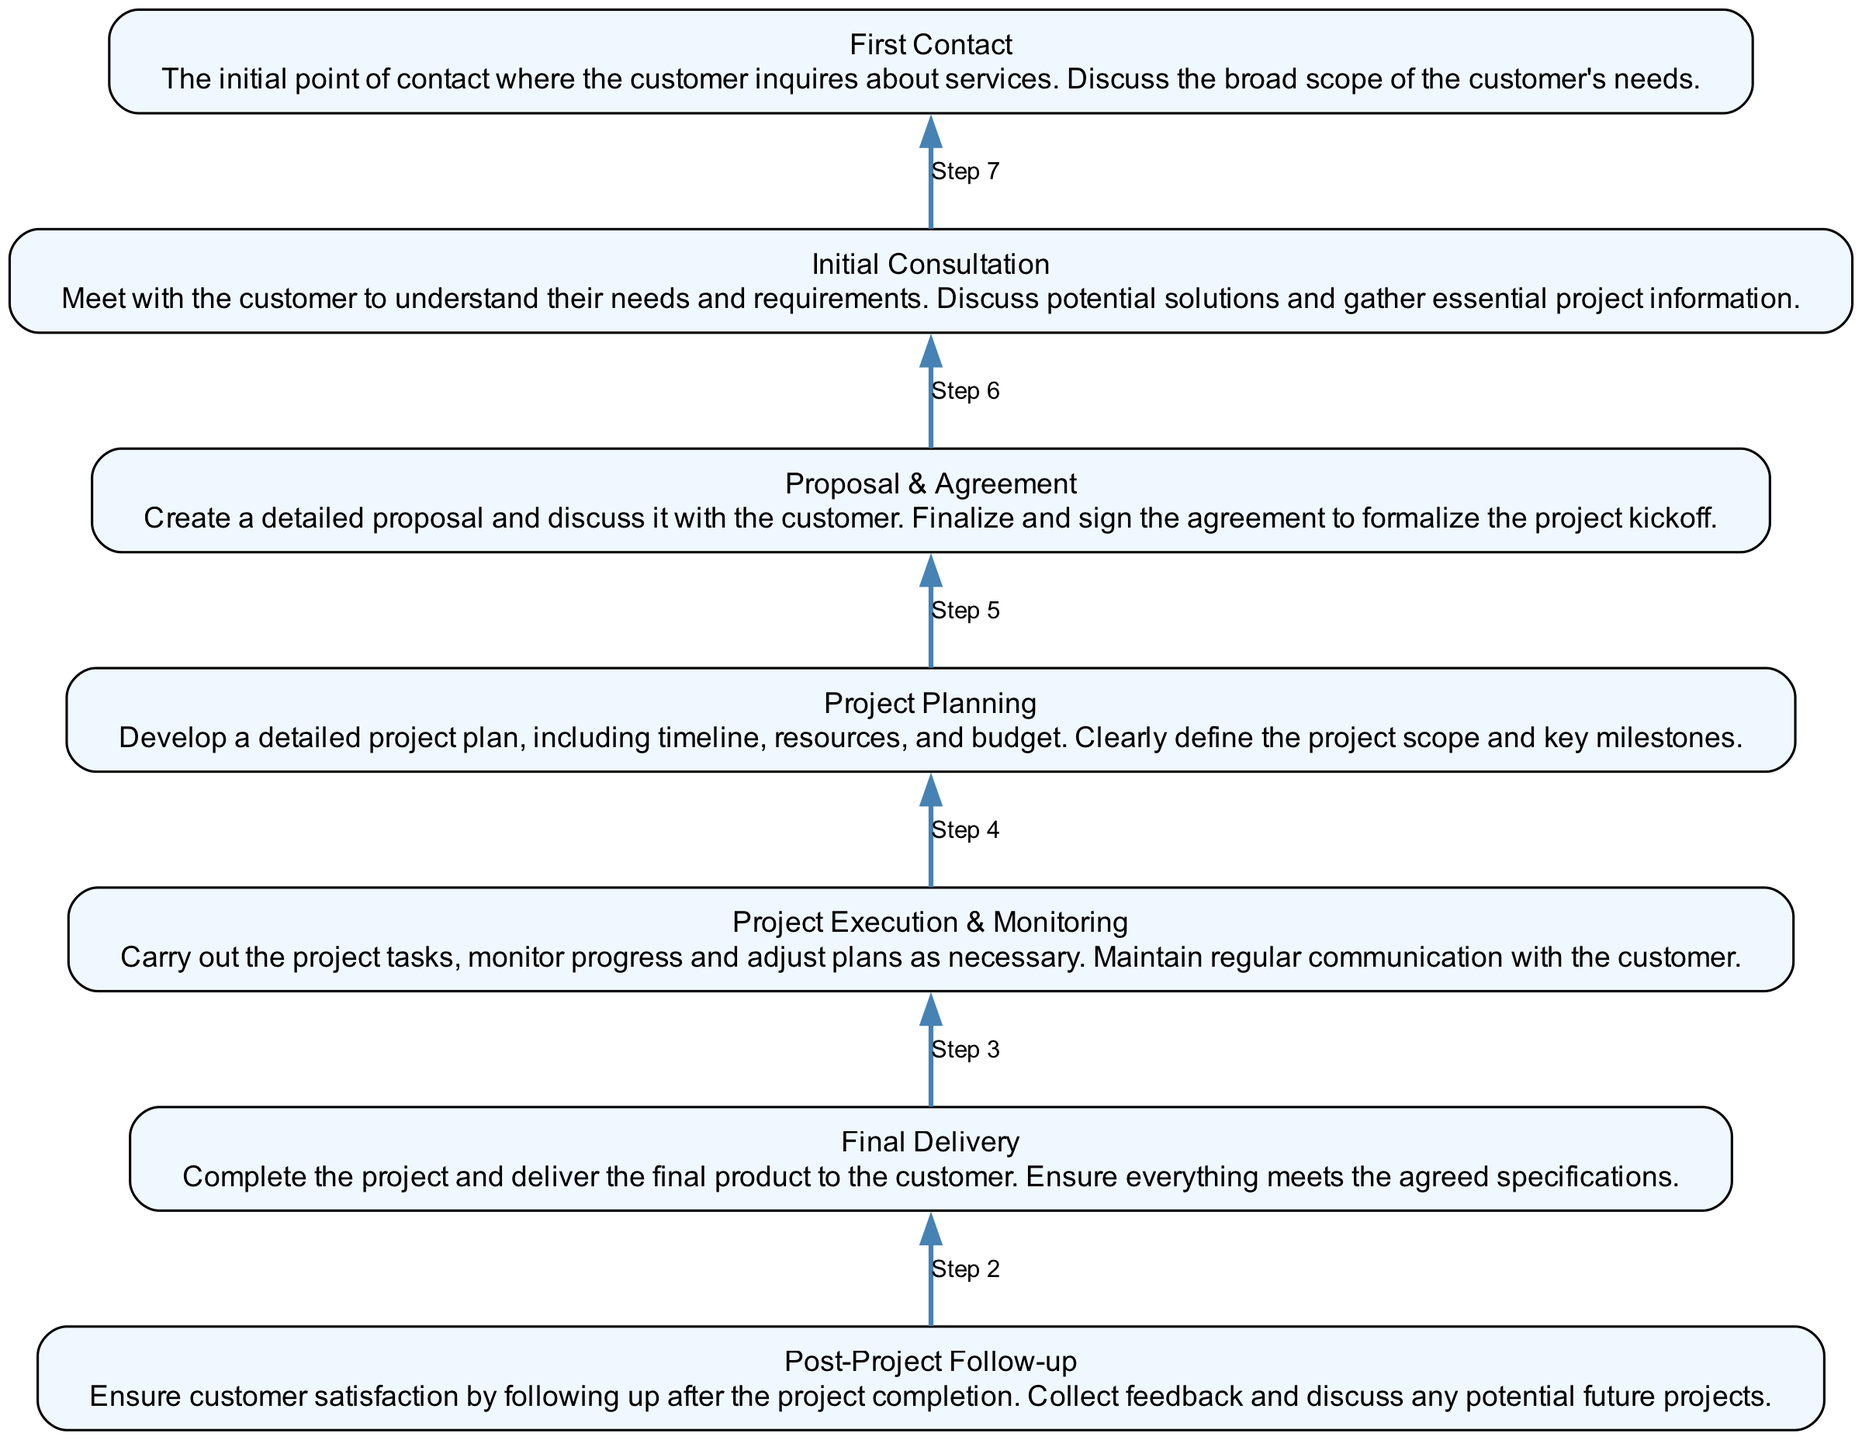What is the last step in the flowchart? The flowchart starts with 'First Contact' at the top and moves to 'Post-Project Follow-up' at the bottom, which is the last step.
Answer: Post-Project Follow-up How many layers are there in the flowchart? There are a total of six layers in the flowchart, listed from 'First Contact' down to 'Post-Project Follow-up'.
Answer: Six What is the description of the 'Proposal & Agreement' layer? The flowchart shows that 'Proposal & Agreement' is described as creating a detailed proposal and discussing it with the customer, followed by finalizing and signing the agreement.
Answer: Create a detailed proposal and discuss it with the customer. Finalize and sign the agreement to formalize the project kickoff What is the relationship between 'Project Planning' and 'Final Delivery'? 'Project Planning' is an earlier step that outlines the project’s details necessary for successful execution, indirectly impacting the quality of the 'Final Delivery'.
Answer: Project Planning affects Final Delivery What is the purpose of the 'Initial Consultation' step? This step is the first interaction where the goal is to gather the customer's needs and requirements, to understand their project expectations.
Answer: Understand their needs and requirements What step comes immediately before 'Final Delivery'? According to the flowchart, the step that occurs immediately before 'Final Delivery' is 'Project Execution & Monitoring', which ensures the project is on track for delivery.
Answer: Project Execution & Monitoring How does 'Project Execution & Monitoring' relate to 'Post-Project Follow-up'? 'Project Execution & Monitoring' ensures the project is properly managed, which is essential for achieving customer satisfaction addressed in 'Post-Project Follow-up'.
Answer: Ensures proper management for satisfaction What is the main focus of the 'First Contact' layer? The 'First Contact' layer is primarily focused on the initial inquiries made by the customer regarding services, allowing for a broad discussion about their needs.
Answer: Initial inquiries about services 